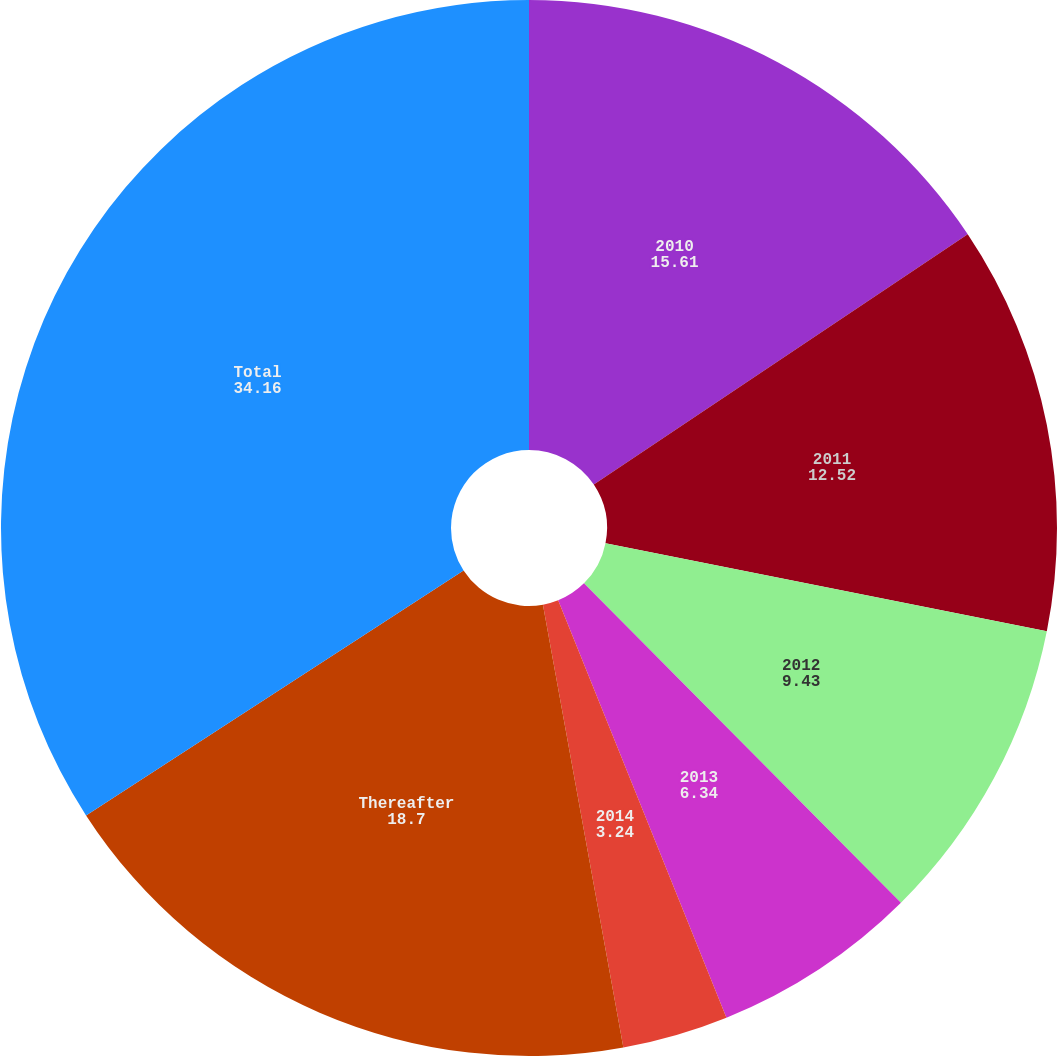Convert chart. <chart><loc_0><loc_0><loc_500><loc_500><pie_chart><fcel>2010<fcel>2011<fcel>2012<fcel>2013<fcel>2014<fcel>Thereafter<fcel>Total<nl><fcel>15.61%<fcel>12.52%<fcel>9.43%<fcel>6.34%<fcel>3.24%<fcel>18.7%<fcel>34.16%<nl></chart> 